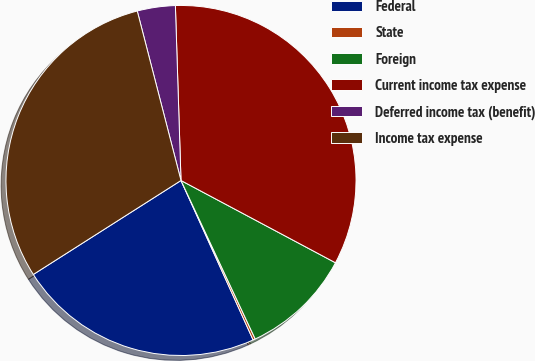<chart> <loc_0><loc_0><loc_500><loc_500><pie_chart><fcel>Federal<fcel>State<fcel>Foreign<fcel>Current income tax expense<fcel>Deferred income tax (benefit)<fcel>Income tax expense<nl><fcel>22.74%<fcel>0.21%<fcel>10.24%<fcel>33.3%<fcel>3.51%<fcel>30.0%<nl></chart> 